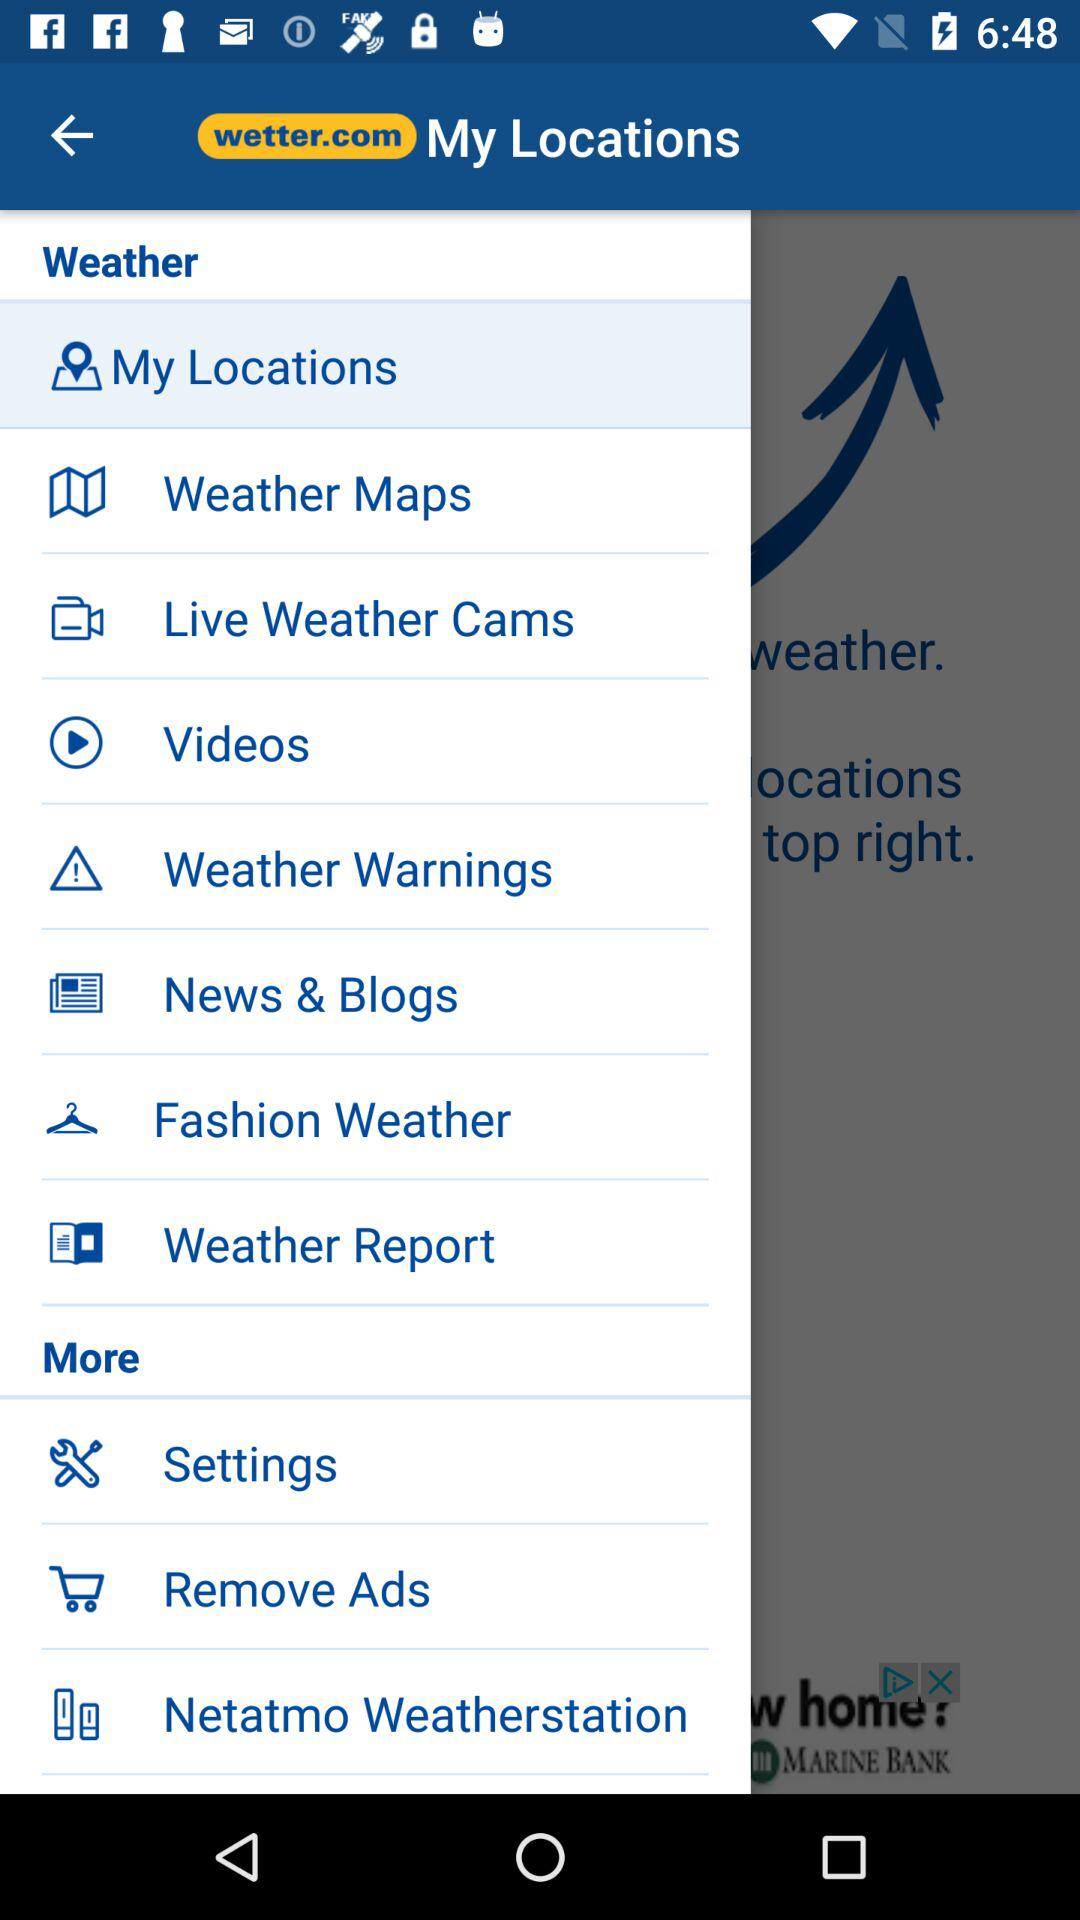What is the application name? The application name is "wetter.com". 